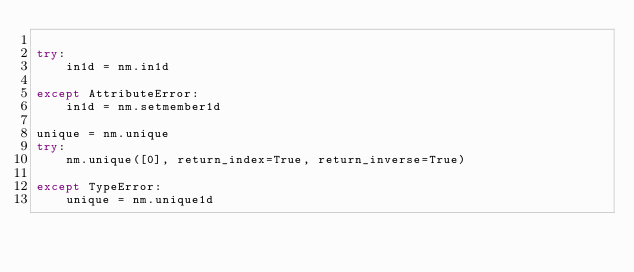Convert code to text. <code><loc_0><loc_0><loc_500><loc_500><_Python_>
try:
    in1d = nm.in1d

except AttributeError:
    in1d = nm.setmember1d

unique = nm.unique
try:
    nm.unique([0], return_index=True, return_inverse=True)

except TypeError:
    unique = nm.unique1d
</code> 